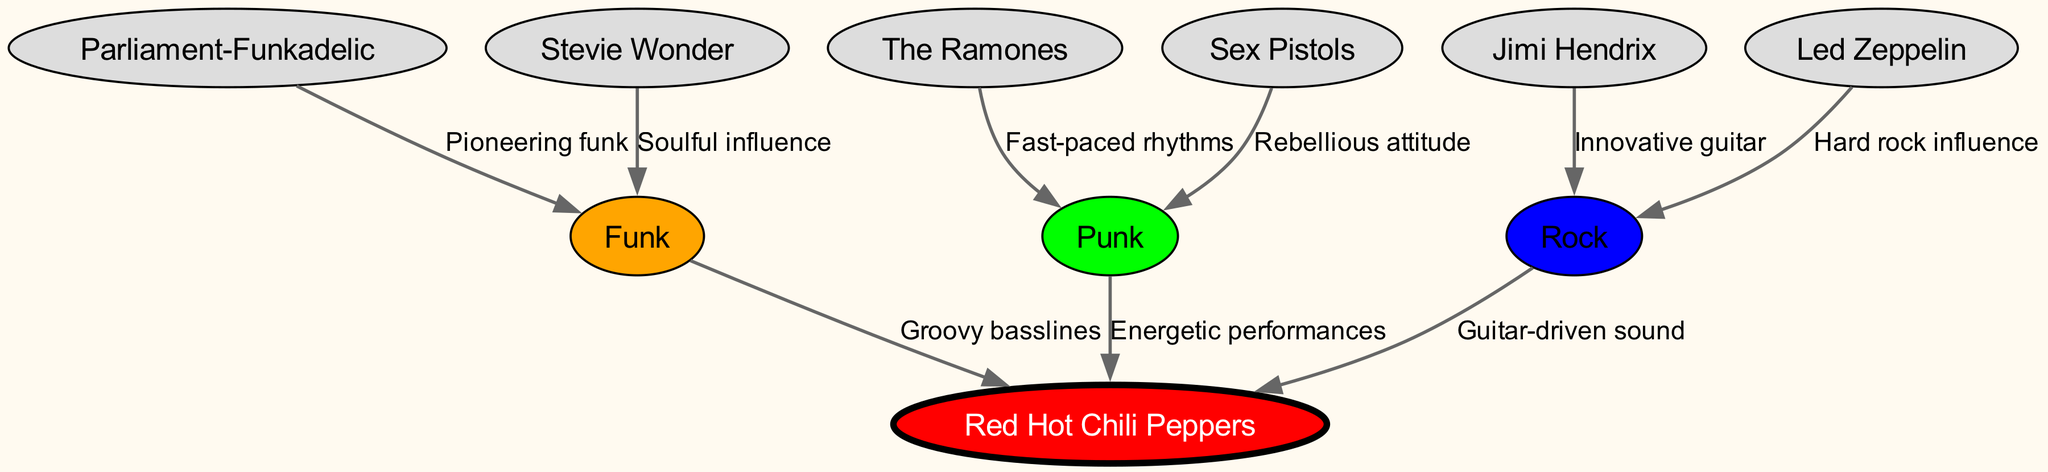What is the central node in this diagram? The central node in the diagram is "Red Hot Chili Peppers," which connects to multiple genres that influence their musical style.
Answer: Red Hot Chili Peppers How many genres are represented as nodes? The diagram shows three genres: Funk, Punk, and Rock. These are the main influences on the Red Hot Chili Peppers' musical style.
Answer: 3 Which artist is connected to the Funk genre? Both Parliament-Funkadelic and Stevie Wonder are connected to the Funk genre, highlighting influential artists in that style.
Answer: Parliament-Funkadelic, Stevie Wonder What does the edge between Funk and Red Hot Chili Peppers label? The edge connecting Funk to Red Hot Chili Peppers is labeled "Groovy basslines," indicating a specific characteristic that RHCP draws from Funk.
Answer: Groovy basslines Which band is known for fast-paced rhythms in the Punk genre? The Ramones are known for fast-paced rhythms and are connected to the Punk genre in the diagram.
Answer: The Ramones What type of influence is described between Jimi Hendrix and Rock? The edge between Jimi Hendrix and Rock is labeled "Innovative guitar," indicating his significant contribution to the Rock genre.
Answer: Innovative guitar How many edges are there in total in this directed graph? The directed graph contains a total of nine edges, which represent the various influences and relationships between the nodes.
Answer: 9 Which genre influences the Red Hot Chili Peppers the most according to the edges? The influences are roughly equal, but Funk specifically has a labeled edge ("Groovy basslines") directly connecting to Red Hot Chili Peppers.
Answer: Funk What is the relationship between Sex Pistols and Punk? The edge connecting Sex Pistols to the Punk genre is labeled "Rebellious attitude," showcasing their notable contribution to the style.
Answer: Rebellious attitude 